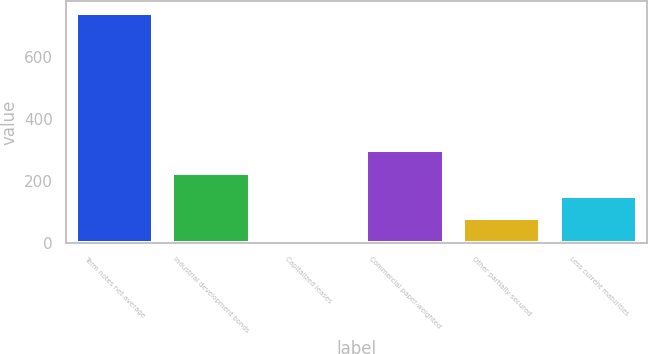<chart> <loc_0><loc_0><loc_500><loc_500><bar_chart><fcel>Term notes net-average<fcel>Industrial development bonds<fcel>Capitalized leases<fcel>Commercial paper-weighted<fcel>Other partially secured<fcel>Less current maturities<nl><fcel>742.5<fcel>226.25<fcel>5<fcel>300<fcel>78.75<fcel>152.5<nl></chart> 